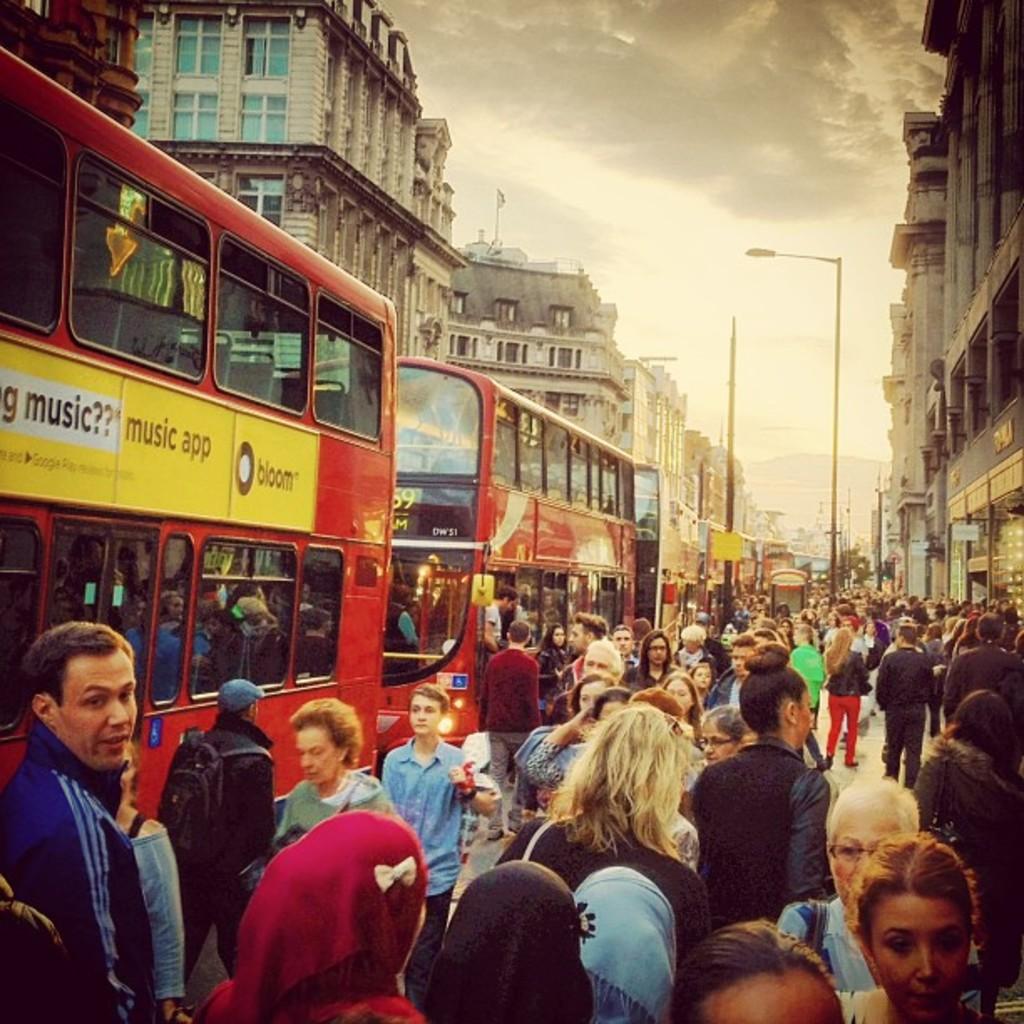What kind of app is advertised on the bus?
Make the answer very short. Music. 